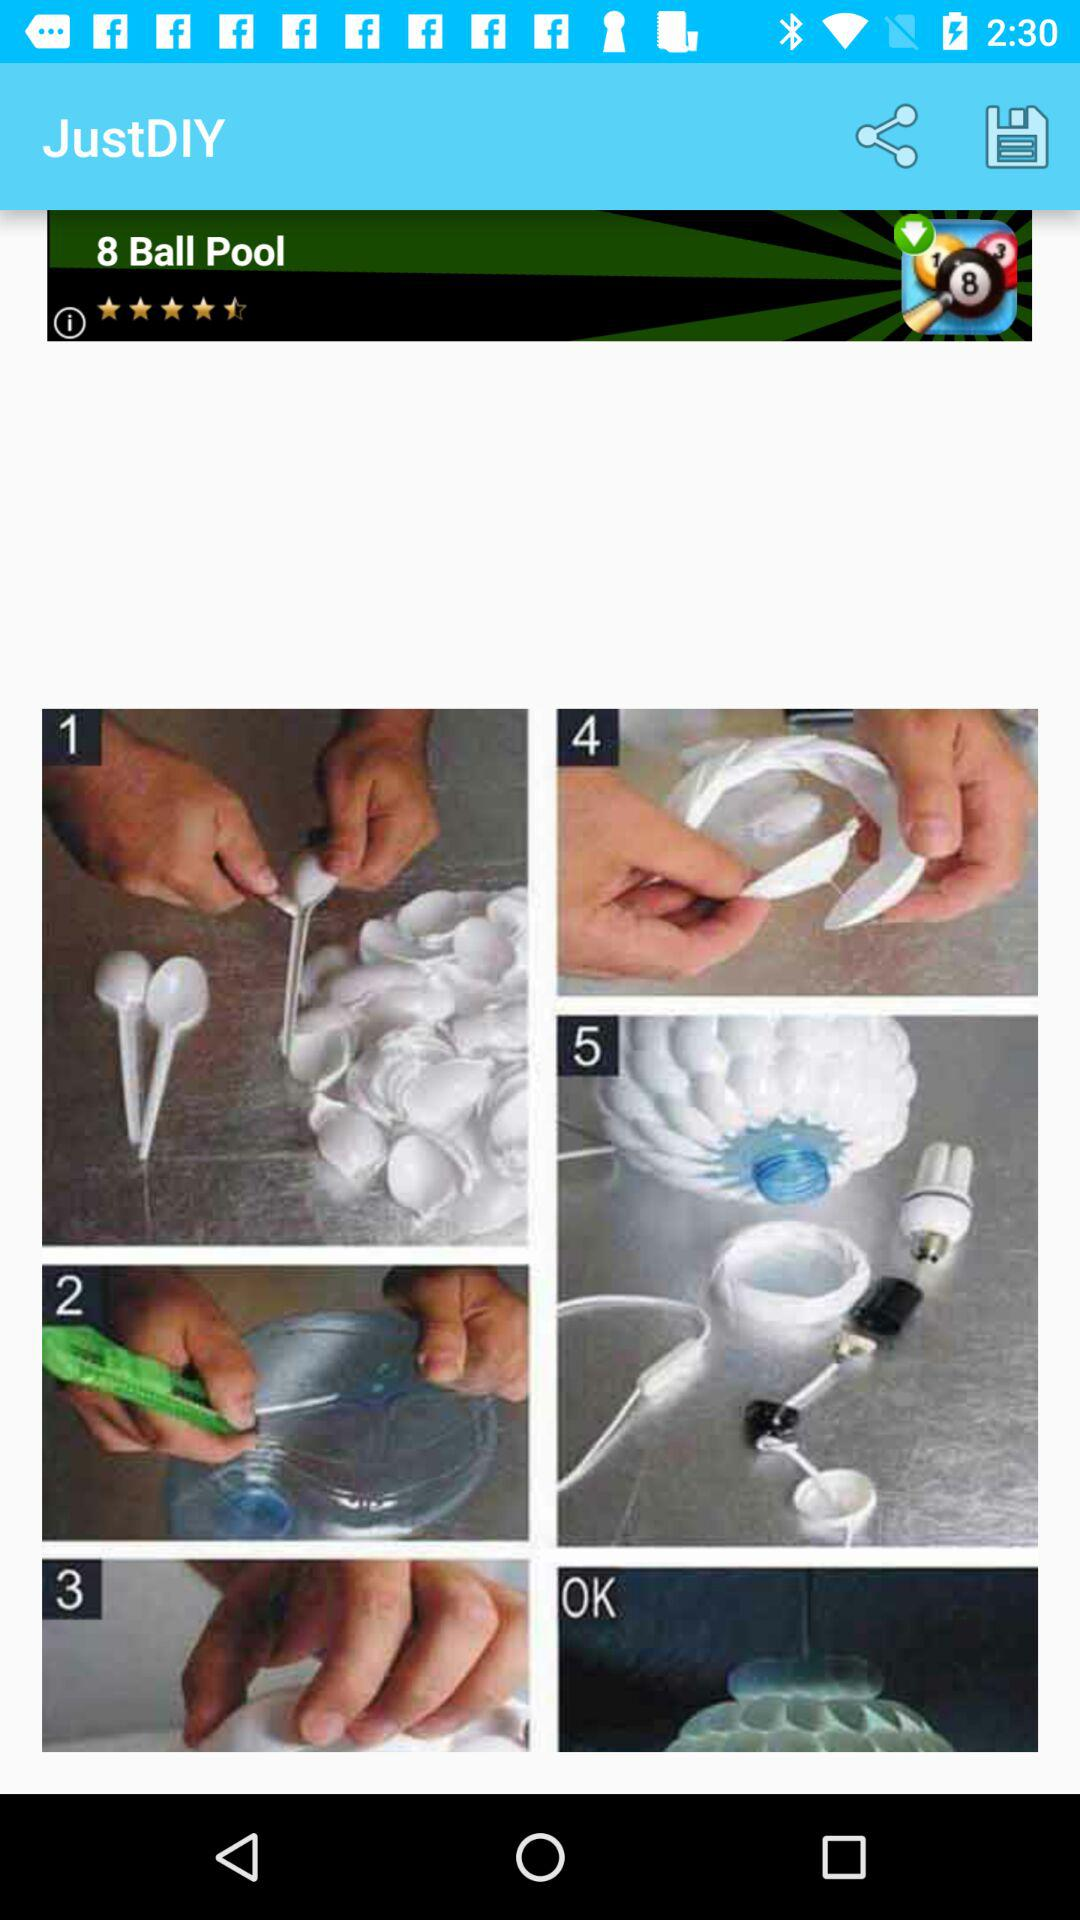What is the name of the application? The name of the application is "JustDIY". 